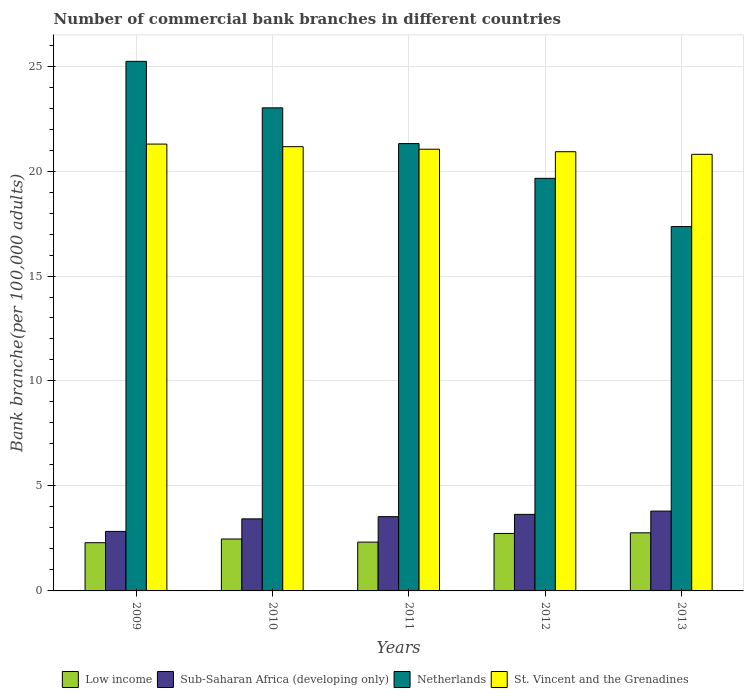Are the number of bars per tick equal to the number of legend labels?
Make the answer very short. Yes. What is the number of commercial bank branches in St. Vincent and the Grenadines in 2012?
Keep it short and to the point. 20.92. Across all years, what is the maximum number of commercial bank branches in St. Vincent and the Grenadines?
Keep it short and to the point. 21.28. Across all years, what is the minimum number of commercial bank branches in Netherlands?
Keep it short and to the point. 17.35. In which year was the number of commercial bank branches in St. Vincent and the Grenadines minimum?
Give a very brief answer. 2013. What is the total number of commercial bank branches in Low income in the graph?
Make the answer very short. 12.6. What is the difference between the number of commercial bank branches in Low income in 2011 and that in 2013?
Give a very brief answer. -0.44. What is the difference between the number of commercial bank branches in Sub-Saharan Africa (developing only) in 2010 and the number of commercial bank branches in Netherlands in 2012?
Your answer should be compact. -16.22. What is the average number of commercial bank branches in St. Vincent and the Grenadines per year?
Make the answer very short. 21.04. In the year 2013, what is the difference between the number of commercial bank branches in St. Vincent and the Grenadines and number of commercial bank branches in Low income?
Give a very brief answer. 18.03. What is the ratio of the number of commercial bank branches in St. Vincent and the Grenadines in 2009 to that in 2013?
Offer a terse response. 1.02. Is the difference between the number of commercial bank branches in St. Vincent and the Grenadines in 2009 and 2011 greater than the difference between the number of commercial bank branches in Low income in 2009 and 2011?
Offer a very short reply. Yes. What is the difference between the highest and the second highest number of commercial bank branches in Netherlands?
Make the answer very short. 2.21. What is the difference between the highest and the lowest number of commercial bank branches in Low income?
Offer a terse response. 0.47. In how many years, is the number of commercial bank branches in Sub-Saharan Africa (developing only) greater than the average number of commercial bank branches in Sub-Saharan Africa (developing only) taken over all years?
Your response must be concise. 3. What does the 2nd bar from the left in 2011 represents?
Make the answer very short. Sub-Saharan Africa (developing only). What does the 1st bar from the right in 2010 represents?
Give a very brief answer. St. Vincent and the Grenadines. Is it the case that in every year, the sum of the number of commercial bank branches in Netherlands and number of commercial bank branches in Sub-Saharan Africa (developing only) is greater than the number of commercial bank branches in Low income?
Ensure brevity in your answer.  Yes. What is the difference between two consecutive major ticks on the Y-axis?
Offer a terse response. 5. Are the values on the major ticks of Y-axis written in scientific E-notation?
Keep it short and to the point. No. How many legend labels are there?
Keep it short and to the point. 4. What is the title of the graph?
Provide a succinct answer. Number of commercial bank branches in different countries. What is the label or title of the Y-axis?
Provide a succinct answer. Bank branche(per 100,0 adults). What is the Bank branche(per 100,000 adults) in Low income in 2009?
Provide a succinct answer. 2.3. What is the Bank branche(per 100,000 adults) in Sub-Saharan Africa (developing only) in 2009?
Offer a very short reply. 2.83. What is the Bank branche(per 100,000 adults) in Netherlands in 2009?
Ensure brevity in your answer.  25.22. What is the Bank branche(per 100,000 adults) of St. Vincent and the Grenadines in 2009?
Your answer should be compact. 21.28. What is the Bank branche(per 100,000 adults) of Low income in 2010?
Ensure brevity in your answer.  2.47. What is the Bank branche(per 100,000 adults) of Sub-Saharan Africa (developing only) in 2010?
Offer a terse response. 3.43. What is the Bank branche(per 100,000 adults) in Netherlands in 2010?
Offer a terse response. 23.01. What is the Bank branche(per 100,000 adults) in St. Vincent and the Grenadines in 2010?
Ensure brevity in your answer.  21.16. What is the Bank branche(per 100,000 adults) of Low income in 2011?
Offer a terse response. 2.32. What is the Bank branche(per 100,000 adults) of Sub-Saharan Africa (developing only) in 2011?
Ensure brevity in your answer.  3.54. What is the Bank branche(per 100,000 adults) of Netherlands in 2011?
Your answer should be very brief. 21.31. What is the Bank branche(per 100,000 adults) of St. Vincent and the Grenadines in 2011?
Offer a terse response. 21.04. What is the Bank branche(per 100,000 adults) of Low income in 2012?
Give a very brief answer. 2.74. What is the Bank branche(per 100,000 adults) of Sub-Saharan Africa (developing only) in 2012?
Provide a short and direct response. 3.65. What is the Bank branche(per 100,000 adults) in Netherlands in 2012?
Make the answer very short. 19.65. What is the Bank branche(per 100,000 adults) of St. Vincent and the Grenadines in 2012?
Keep it short and to the point. 20.92. What is the Bank branche(per 100,000 adults) in Low income in 2013?
Offer a very short reply. 2.77. What is the Bank branche(per 100,000 adults) of Sub-Saharan Africa (developing only) in 2013?
Provide a succinct answer. 3.8. What is the Bank branche(per 100,000 adults) of Netherlands in 2013?
Provide a short and direct response. 17.35. What is the Bank branche(per 100,000 adults) in St. Vincent and the Grenadines in 2013?
Make the answer very short. 20.8. Across all years, what is the maximum Bank branche(per 100,000 adults) of Low income?
Offer a terse response. 2.77. Across all years, what is the maximum Bank branche(per 100,000 adults) in Sub-Saharan Africa (developing only)?
Keep it short and to the point. 3.8. Across all years, what is the maximum Bank branche(per 100,000 adults) in Netherlands?
Make the answer very short. 25.22. Across all years, what is the maximum Bank branche(per 100,000 adults) of St. Vincent and the Grenadines?
Your answer should be compact. 21.28. Across all years, what is the minimum Bank branche(per 100,000 adults) of Low income?
Give a very brief answer. 2.3. Across all years, what is the minimum Bank branche(per 100,000 adults) in Sub-Saharan Africa (developing only)?
Your response must be concise. 2.83. Across all years, what is the minimum Bank branche(per 100,000 adults) of Netherlands?
Offer a terse response. 17.35. Across all years, what is the minimum Bank branche(per 100,000 adults) in St. Vincent and the Grenadines?
Provide a succinct answer. 20.8. What is the total Bank branche(per 100,000 adults) of Low income in the graph?
Offer a very short reply. 12.6. What is the total Bank branche(per 100,000 adults) in Sub-Saharan Africa (developing only) in the graph?
Your answer should be very brief. 17.25. What is the total Bank branche(per 100,000 adults) in Netherlands in the graph?
Offer a very short reply. 106.55. What is the total Bank branche(per 100,000 adults) of St. Vincent and the Grenadines in the graph?
Offer a terse response. 105.2. What is the difference between the Bank branche(per 100,000 adults) in Low income in 2009 and that in 2010?
Your answer should be very brief. -0.18. What is the difference between the Bank branche(per 100,000 adults) of Sub-Saharan Africa (developing only) in 2009 and that in 2010?
Provide a short and direct response. -0.6. What is the difference between the Bank branche(per 100,000 adults) of Netherlands in 2009 and that in 2010?
Your answer should be very brief. 2.21. What is the difference between the Bank branche(per 100,000 adults) in St. Vincent and the Grenadines in 2009 and that in 2010?
Provide a succinct answer. 0.12. What is the difference between the Bank branche(per 100,000 adults) of Low income in 2009 and that in 2011?
Offer a terse response. -0.03. What is the difference between the Bank branche(per 100,000 adults) in Sub-Saharan Africa (developing only) in 2009 and that in 2011?
Ensure brevity in your answer.  -0.7. What is the difference between the Bank branche(per 100,000 adults) in Netherlands in 2009 and that in 2011?
Give a very brief answer. 3.92. What is the difference between the Bank branche(per 100,000 adults) in St. Vincent and the Grenadines in 2009 and that in 2011?
Your response must be concise. 0.24. What is the difference between the Bank branche(per 100,000 adults) in Low income in 2009 and that in 2012?
Your answer should be compact. -0.44. What is the difference between the Bank branche(per 100,000 adults) in Sub-Saharan Africa (developing only) in 2009 and that in 2012?
Keep it short and to the point. -0.81. What is the difference between the Bank branche(per 100,000 adults) in Netherlands in 2009 and that in 2012?
Your response must be concise. 5.57. What is the difference between the Bank branche(per 100,000 adults) in St. Vincent and the Grenadines in 2009 and that in 2012?
Ensure brevity in your answer.  0.36. What is the difference between the Bank branche(per 100,000 adults) in Low income in 2009 and that in 2013?
Your response must be concise. -0.47. What is the difference between the Bank branche(per 100,000 adults) of Sub-Saharan Africa (developing only) in 2009 and that in 2013?
Provide a short and direct response. -0.97. What is the difference between the Bank branche(per 100,000 adults) in Netherlands in 2009 and that in 2013?
Your answer should be very brief. 7.87. What is the difference between the Bank branche(per 100,000 adults) in St. Vincent and the Grenadines in 2009 and that in 2013?
Ensure brevity in your answer.  0.49. What is the difference between the Bank branche(per 100,000 adults) of Low income in 2010 and that in 2011?
Offer a terse response. 0.15. What is the difference between the Bank branche(per 100,000 adults) in Sub-Saharan Africa (developing only) in 2010 and that in 2011?
Your answer should be compact. -0.11. What is the difference between the Bank branche(per 100,000 adults) in Netherlands in 2010 and that in 2011?
Your answer should be compact. 1.7. What is the difference between the Bank branche(per 100,000 adults) in St. Vincent and the Grenadines in 2010 and that in 2011?
Your response must be concise. 0.12. What is the difference between the Bank branche(per 100,000 adults) in Low income in 2010 and that in 2012?
Provide a short and direct response. -0.26. What is the difference between the Bank branche(per 100,000 adults) of Sub-Saharan Africa (developing only) in 2010 and that in 2012?
Your response must be concise. -0.21. What is the difference between the Bank branche(per 100,000 adults) in Netherlands in 2010 and that in 2012?
Give a very brief answer. 3.36. What is the difference between the Bank branche(per 100,000 adults) in St. Vincent and the Grenadines in 2010 and that in 2012?
Make the answer very short. 0.24. What is the difference between the Bank branche(per 100,000 adults) in Low income in 2010 and that in 2013?
Provide a short and direct response. -0.3. What is the difference between the Bank branche(per 100,000 adults) in Sub-Saharan Africa (developing only) in 2010 and that in 2013?
Offer a very short reply. -0.37. What is the difference between the Bank branche(per 100,000 adults) of Netherlands in 2010 and that in 2013?
Offer a very short reply. 5.66. What is the difference between the Bank branche(per 100,000 adults) of St. Vincent and the Grenadines in 2010 and that in 2013?
Provide a short and direct response. 0.36. What is the difference between the Bank branche(per 100,000 adults) of Low income in 2011 and that in 2012?
Your answer should be compact. -0.41. What is the difference between the Bank branche(per 100,000 adults) in Sub-Saharan Africa (developing only) in 2011 and that in 2012?
Keep it short and to the point. -0.11. What is the difference between the Bank branche(per 100,000 adults) of Netherlands in 2011 and that in 2012?
Keep it short and to the point. 1.66. What is the difference between the Bank branche(per 100,000 adults) of St. Vincent and the Grenadines in 2011 and that in 2012?
Give a very brief answer. 0.12. What is the difference between the Bank branche(per 100,000 adults) in Low income in 2011 and that in 2013?
Your answer should be compact. -0.44. What is the difference between the Bank branche(per 100,000 adults) of Sub-Saharan Africa (developing only) in 2011 and that in 2013?
Ensure brevity in your answer.  -0.26. What is the difference between the Bank branche(per 100,000 adults) of Netherlands in 2011 and that in 2013?
Keep it short and to the point. 3.95. What is the difference between the Bank branche(per 100,000 adults) of St. Vincent and the Grenadines in 2011 and that in 2013?
Your answer should be very brief. 0.24. What is the difference between the Bank branche(per 100,000 adults) in Low income in 2012 and that in 2013?
Provide a succinct answer. -0.03. What is the difference between the Bank branche(per 100,000 adults) in Sub-Saharan Africa (developing only) in 2012 and that in 2013?
Keep it short and to the point. -0.16. What is the difference between the Bank branche(per 100,000 adults) of Netherlands in 2012 and that in 2013?
Provide a succinct answer. 2.3. What is the difference between the Bank branche(per 100,000 adults) in St. Vincent and the Grenadines in 2012 and that in 2013?
Offer a terse response. 0.12. What is the difference between the Bank branche(per 100,000 adults) of Low income in 2009 and the Bank branche(per 100,000 adults) of Sub-Saharan Africa (developing only) in 2010?
Your answer should be compact. -1.14. What is the difference between the Bank branche(per 100,000 adults) of Low income in 2009 and the Bank branche(per 100,000 adults) of Netherlands in 2010?
Keep it short and to the point. -20.71. What is the difference between the Bank branche(per 100,000 adults) of Low income in 2009 and the Bank branche(per 100,000 adults) of St. Vincent and the Grenadines in 2010?
Provide a succinct answer. -18.86. What is the difference between the Bank branche(per 100,000 adults) of Sub-Saharan Africa (developing only) in 2009 and the Bank branche(per 100,000 adults) of Netherlands in 2010?
Keep it short and to the point. -20.18. What is the difference between the Bank branche(per 100,000 adults) of Sub-Saharan Africa (developing only) in 2009 and the Bank branche(per 100,000 adults) of St. Vincent and the Grenadines in 2010?
Your response must be concise. -18.33. What is the difference between the Bank branche(per 100,000 adults) of Netherlands in 2009 and the Bank branche(per 100,000 adults) of St. Vincent and the Grenadines in 2010?
Your response must be concise. 4.06. What is the difference between the Bank branche(per 100,000 adults) in Low income in 2009 and the Bank branche(per 100,000 adults) in Sub-Saharan Africa (developing only) in 2011?
Your answer should be very brief. -1.24. What is the difference between the Bank branche(per 100,000 adults) in Low income in 2009 and the Bank branche(per 100,000 adults) in Netherlands in 2011?
Ensure brevity in your answer.  -19.01. What is the difference between the Bank branche(per 100,000 adults) in Low income in 2009 and the Bank branche(per 100,000 adults) in St. Vincent and the Grenadines in 2011?
Offer a very short reply. -18.74. What is the difference between the Bank branche(per 100,000 adults) of Sub-Saharan Africa (developing only) in 2009 and the Bank branche(per 100,000 adults) of Netherlands in 2011?
Keep it short and to the point. -18.47. What is the difference between the Bank branche(per 100,000 adults) of Sub-Saharan Africa (developing only) in 2009 and the Bank branche(per 100,000 adults) of St. Vincent and the Grenadines in 2011?
Keep it short and to the point. -18.2. What is the difference between the Bank branche(per 100,000 adults) of Netherlands in 2009 and the Bank branche(per 100,000 adults) of St. Vincent and the Grenadines in 2011?
Offer a terse response. 4.19. What is the difference between the Bank branche(per 100,000 adults) in Low income in 2009 and the Bank branche(per 100,000 adults) in Sub-Saharan Africa (developing only) in 2012?
Offer a terse response. -1.35. What is the difference between the Bank branche(per 100,000 adults) in Low income in 2009 and the Bank branche(per 100,000 adults) in Netherlands in 2012?
Your response must be concise. -17.35. What is the difference between the Bank branche(per 100,000 adults) of Low income in 2009 and the Bank branche(per 100,000 adults) of St. Vincent and the Grenadines in 2012?
Your answer should be compact. -18.62. What is the difference between the Bank branche(per 100,000 adults) in Sub-Saharan Africa (developing only) in 2009 and the Bank branche(per 100,000 adults) in Netherlands in 2012?
Offer a very short reply. -16.82. What is the difference between the Bank branche(per 100,000 adults) of Sub-Saharan Africa (developing only) in 2009 and the Bank branche(per 100,000 adults) of St. Vincent and the Grenadines in 2012?
Your answer should be very brief. -18.09. What is the difference between the Bank branche(per 100,000 adults) of Netherlands in 2009 and the Bank branche(per 100,000 adults) of St. Vincent and the Grenadines in 2012?
Provide a succinct answer. 4.3. What is the difference between the Bank branche(per 100,000 adults) of Low income in 2009 and the Bank branche(per 100,000 adults) of Sub-Saharan Africa (developing only) in 2013?
Provide a short and direct response. -1.51. What is the difference between the Bank branche(per 100,000 adults) of Low income in 2009 and the Bank branche(per 100,000 adults) of Netherlands in 2013?
Keep it short and to the point. -15.06. What is the difference between the Bank branche(per 100,000 adults) in Low income in 2009 and the Bank branche(per 100,000 adults) in St. Vincent and the Grenadines in 2013?
Provide a short and direct response. -18.5. What is the difference between the Bank branche(per 100,000 adults) in Sub-Saharan Africa (developing only) in 2009 and the Bank branche(per 100,000 adults) in Netherlands in 2013?
Keep it short and to the point. -14.52. What is the difference between the Bank branche(per 100,000 adults) in Sub-Saharan Africa (developing only) in 2009 and the Bank branche(per 100,000 adults) in St. Vincent and the Grenadines in 2013?
Provide a short and direct response. -17.96. What is the difference between the Bank branche(per 100,000 adults) in Netherlands in 2009 and the Bank branche(per 100,000 adults) in St. Vincent and the Grenadines in 2013?
Offer a terse response. 4.43. What is the difference between the Bank branche(per 100,000 adults) in Low income in 2010 and the Bank branche(per 100,000 adults) in Sub-Saharan Africa (developing only) in 2011?
Keep it short and to the point. -1.06. What is the difference between the Bank branche(per 100,000 adults) of Low income in 2010 and the Bank branche(per 100,000 adults) of Netherlands in 2011?
Offer a very short reply. -18.83. What is the difference between the Bank branche(per 100,000 adults) in Low income in 2010 and the Bank branche(per 100,000 adults) in St. Vincent and the Grenadines in 2011?
Provide a succinct answer. -18.57. What is the difference between the Bank branche(per 100,000 adults) of Sub-Saharan Africa (developing only) in 2010 and the Bank branche(per 100,000 adults) of Netherlands in 2011?
Your response must be concise. -17.88. What is the difference between the Bank branche(per 100,000 adults) in Sub-Saharan Africa (developing only) in 2010 and the Bank branche(per 100,000 adults) in St. Vincent and the Grenadines in 2011?
Your response must be concise. -17.61. What is the difference between the Bank branche(per 100,000 adults) in Netherlands in 2010 and the Bank branche(per 100,000 adults) in St. Vincent and the Grenadines in 2011?
Your answer should be compact. 1.97. What is the difference between the Bank branche(per 100,000 adults) of Low income in 2010 and the Bank branche(per 100,000 adults) of Sub-Saharan Africa (developing only) in 2012?
Keep it short and to the point. -1.17. What is the difference between the Bank branche(per 100,000 adults) of Low income in 2010 and the Bank branche(per 100,000 adults) of Netherlands in 2012?
Offer a very short reply. -17.18. What is the difference between the Bank branche(per 100,000 adults) of Low income in 2010 and the Bank branche(per 100,000 adults) of St. Vincent and the Grenadines in 2012?
Your answer should be compact. -18.45. What is the difference between the Bank branche(per 100,000 adults) of Sub-Saharan Africa (developing only) in 2010 and the Bank branche(per 100,000 adults) of Netherlands in 2012?
Provide a succinct answer. -16.22. What is the difference between the Bank branche(per 100,000 adults) in Sub-Saharan Africa (developing only) in 2010 and the Bank branche(per 100,000 adults) in St. Vincent and the Grenadines in 2012?
Your response must be concise. -17.49. What is the difference between the Bank branche(per 100,000 adults) of Netherlands in 2010 and the Bank branche(per 100,000 adults) of St. Vincent and the Grenadines in 2012?
Keep it short and to the point. 2.09. What is the difference between the Bank branche(per 100,000 adults) in Low income in 2010 and the Bank branche(per 100,000 adults) in Sub-Saharan Africa (developing only) in 2013?
Offer a terse response. -1.33. What is the difference between the Bank branche(per 100,000 adults) of Low income in 2010 and the Bank branche(per 100,000 adults) of Netherlands in 2013?
Ensure brevity in your answer.  -14.88. What is the difference between the Bank branche(per 100,000 adults) in Low income in 2010 and the Bank branche(per 100,000 adults) in St. Vincent and the Grenadines in 2013?
Provide a short and direct response. -18.32. What is the difference between the Bank branche(per 100,000 adults) in Sub-Saharan Africa (developing only) in 2010 and the Bank branche(per 100,000 adults) in Netherlands in 2013?
Your response must be concise. -13.92. What is the difference between the Bank branche(per 100,000 adults) in Sub-Saharan Africa (developing only) in 2010 and the Bank branche(per 100,000 adults) in St. Vincent and the Grenadines in 2013?
Give a very brief answer. -17.36. What is the difference between the Bank branche(per 100,000 adults) of Netherlands in 2010 and the Bank branche(per 100,000 adults) of St. Vincent and the Grenadines in 2013?
Make the answer very short. 2.21. What is the difference between the Bank branche(per 100,000 adults) of Low income in 2011 and the Bank branche(per 100,000 adults) of Sub-Saharan Africa (developing only) in 2012?
Offer a very short reply. -1.32. What is the difference between the Bank branche(per 100,000 adults) in Low income in 2011 and the Bank branche(per 100,000 adults) in Netherlands in 2012?
Keep it short and to the point. -17.33. What is the difference between the Bank branche(per 100,000 adults) of Low income in 2011 and the Bank branche(per 100,000 adults) of St. Vincent and the Grenadines in 2012?
Your answer should be very brief. -18.6. What is the difference between the Bank branche(per 100,000 adults) of Sub-Saharan Africa (developing only) in 2011 and the Bank branche(per 100,000 adults) of Netherlands in 2012?
Ensure brevity in your answer.  -16.11. What is the difference between the Bank branche(per 100,000 adults) of Sub-Saharan Africa (developing only) in 2011 and the Bank branche(per 100,000 adults) of St. Vincent and the Grenadines in 2012?
Offer a terse response. -17.38. What is the difference between the Bank branche(per 100,000 adults) in Netherlands in 2011 and the Bank branche(per 100,000 adults) in St. Vincent and the Grenadines in 2012?
Provide a short and direct response. 0.39. What is the difference between the Bank branche(per 100,000 adults) in Low income in 2011 and the Bank branche(per 100,000 adults) in Sub-Saharan Africa (developing only) in 2013?
Your answer should be compact. -1.48. What is the difference between the Bank branche(per 100,000 adults) of Low income in 2011 and the Bank branche(per 100,000 adults) of Netherlands in 2013?
Offer a terse response. -15.03. What is the difference between the Bank branche(per 100,000 adults) of Low income in 2011 and the Bank branche(per 100,000 adults) of St. Vincent and the Grenadines in 2013?
Make the answer very short. -18.47. What is the difference between the Bank branche(per 100,000 adults) in Sub-Saharan Africa (developing only) in 2011 and the Bank branche(per 100,000 adults) in Netherlands in 2013?
Your answer should be compact. -13.82. What is the difference between the Bank branche(per 100,000 adults) of Sub-Saharan Africa (developing only) in 2011 and the Bank branche(per 100,000 adults) of St. Vincent and the Grenadines in 2013?
Your answer should be compact. -17.26. What is the difference between the Bank branche(per 100,000 adults) of Netherlands in 2011 and the Bank branche(per 100,000 adults) of St. Vincent and the Grenadines in 2013?
Offer a very short reply. 0.51. What is the difference between the Bank branche(per 100,000 adults) of Low income in 2012 and the Bank branche(per 100,000 adults) of Sub-Saharan Africa (developing only) in 2013?
Provide a succinct answer. -1.07. What is the difference between the Bank branche(per 100,000 adults) of Low income in 2012 and the Bank branche(per 100,000 adults) of Netherlands in 2013?
Offer a very short reply. -14.62. What is the difference between the Bank branche(per 100,000 adults) in Low income in 2012 and the Bank branche(per 100,000 adults) in St. Vincent and the Grenadines in 2013?
Ensure brevity in your answer.  -18.06. What is the difference between the Bank branche(per 100,000 adults) in Sub-Saharan Africa (developing only) in 2012 and the Bank branche(per 100,000 adults) in Netherlands in 2013?
Keep it short and to the point. -13.71. What is the difference between the Bank branche(per 100,000 adults) of Sub-Saharan Africa (developing only) in 2012 and the Bank branche(per 100,000 adults) of St. Vincent and the Grenadines in 2013?
Provide a succinct answer. -17.15. What is the difference between the Bank branche(per 100,000 adults) in Netherlands in 2012 and the Bank branche(per 100,000 adults) in St. Vincent and the Grenadines in 2013?
Offer a terse response. -1.14. What is the average Bank branche(per 100,000 adults) in Low income per year?
Provide a succinct answer. 2.52. What is the average Bank branche(per 100,000 adults) of Sub-Saharan Africa (developing only) per year?
Ensure brevity in your answer.  3.45. What is the average Bank branche(per 100,000 adults) in Netherlands per year?
Your answer should be compact. 21.31. What is the average Bank branche(per 100,000 adults) in St. Vincent and the Grenadines per year?
Give a very brief answer. 21.04. In the year 2009, what is the difference between the Bank branche(per 100,000 adults) in Low income and Bank branche(per 100,000 adults) in Sub-Saharan Africa (developing only)?
Your answer should be compact. -0.54. In the year 2009, what is the difference between the Bank branche(per 100,000 adults) in Low income and Bank branche(per 100,000 adults) in Netherlands?
Provide a succinct answer. -22.93. In the year 2009, what is the difference between the Bank branche(per 100,000 adults) in Low income and Bank branche(per 100,000 adults) in St. Vincent and the Grenadines?
Offer a terse response. -18.99. In the year 2009, what is the difference between the Bank branche(per 100,000 adults) in Sub-Saharan Africa (developing only) and Bank branche(per 100,000 adults) in Netherlands?
Your answer should be very brief. -22.39. In the year 2009, what is the difference between the Bank branche(per 100,000 adults) of Sub-Saharan Africa (developing only) and Bank branche(per 100,000 adults) of St. Vincent and the Grenadines?
Provide a short and direct response. -18.45. In the year 2009, what is the difference between the Bank branche(per 100,000 adults) in Netherlands and Bank branche(per 100,000 adults) in St. Vincent and the Grenadines?
Provide a succinct answer. 3.94. In the year 2010, what is the difference between the Bank branche(per 100,000 adults) in Low income and Bank branche(per 100,000 adults) in Sub-Saharan Africa (developing only)?
Offer a very short reply. -0.96. In the year 2010, what is the difference between the Bank branche(per 100,000 adults) of Low income and Bank branche(per 100,000 adults) of Netherlands?
Keep it short and to the point. -20.54. In the year 2010, what is the difference between the Bank branche(per 100,000 adults) of Low income and Bank branche(per 100,000 adults) of St. Vincent and the Grenadines?
Your answer should be compact. -18.69. In the year 2010, what is the difference between the Bank branche(per 100,000 adults) of Sub-Saharan Africa (developing only) and Bank branche(per 100,000 adults) of Netherlands?
Keep it short and to the point. -19.58. In the year 2010, what is the difference between the Bank branche(per 100,000 adults) in Sub-Saharan Africa (developing only) and Bank branche(per 100,000 adults) in St. Vincent and the Grenadines?
Provide a short and direct response. -17.73. In the year 2010, what is the difference between the Bank branche(per 100,000 adults) in Netherlands and Bank branche(per 100,000 adults) in St. Vincent and the Grenadines?
Keep it short and to the point. 1.85. In the year 2011, what is the difference between the Bank branche(per 100,000 adults) in Low income and Bank branche(per 100,000 adults) in Sub-Saharan Africa (developing only)?
Keep it short and to the point. -1.21. In the year 2011, what is the difference between the Bank branche(per 100,000 adults) of Low income and Bank branche(per 100,000 adults) of Netherlands?
Make the answer very short. -18.98. In the year 2011, what is the difference between the Bank branche(per 100,000 adults) of Low income and Bank branche(per 100,000 adults) of St. Vincent and the Grenadines?
Provide a succinct answer. -18.71. In the year 2011, what is the difference between the Bank branche(per 100,000 adults) in Sub-Saharan Africa (developing only) and Bank branche(per 100,000 adults) in Netherlands?
Provide a short and direct response. -17.77. In the year 2011, what is the difference between the Bank branche(per 100,000 adults) in Sub-Saharan Africa (developing only) and Bank branche(per 100,000 adults) in St. Vincent and the Grenadines?
Your answer should be compact. -17.5. In the year 2011, what is the difference between the Bank branche(per 100,000 adults) of Netherlands and Bank branche(per 100,000 adults) of St. Vincent and the Grenadines?
Your response must be concise. 0.27. In the year 2012, what is the difference between the Bank branche(per 100,000 adults) in Low income and Bank branche(per 100,000 adults) in Sub-Saharan Africa (developing only)?
Keep it short and to the point. -0.91. In the year 2012, what is the difference between the Bank branche(per 100,000 adults) of Low income and Bank branche(per 100,000 adults) of Netherlands?
Make the answer very short. -16.91. In the year 2012, what is the difference between the Bank branche(per 100,000 adults) of Low income and Bank branche(per 100,000 adults) of St. Vincent and the Grenadines?
Provide a short and direct response. -18.18. In the year 2012, what is the difference between the Bank branche(per 100,000 adults) of Sub-Saharan Africa (developing only) and Bank branche(per 100,000 adults) of Netherlands?
Your answer should be very brief. -16.01. In the year 2012, what is the difference between the Bank branche(per 100,000 adults) of Sub-Saharan Africa (developing only) and Bank branche(per 100,000 adults) of St. Vincent and the Grenadines?
Keep it short and to the point. -17.27. In the year 2012, what is the difference between the Bank branche(per 100,000 adults) in Netherlands and Bank branche(per 100,000 adults) in St. Vincent and the Grenadines?
Keep it short and to the point. -1.27. In the year 2013, what is the difference between the Bank branche(per 100,000 adults) of Low income and Bank branche(per 100,000 adults) of Sub-Saharan Africa (developing only)?
Provide a short and direct response. -1.03. In the year 2013, what is the difference between the Bank branche(per 100,000 adults) of Low income and Bank branche(per 100,000 adults) of Netherlands?
Ensure brevity in your answer.  -14.59. In the year 2013, what is the difference between the Bank branche(per 100,000 adults) of Low income and Bank branche(per 100,000 adults) of St. Vincent and the Grenadines?
Your response must be concise. -18.03. In the year 2013, what is the difference between the Bank branche(per 100,000 adults) in Sub-Saharan Africa (developing only) and Bank branche(per 100,000 adults) in Netherlands?
Your answer should be very brief. -13.55. In the year 2013, what is the difference between the Bank branche(per 100,000 adults) of Sub-Saharan Africa (developing only) and Bank branche(per 100,000 adults) of St. Vincent and the Grenadines?
Make the answer very short. -16.99. In the year 2013, what is the difference between the Bank branche(per 100,000 adults) of Netherlands and Bank branche(per 100,000 adults) of St. Vincent and the Grenadines?
Offer a terse response. -3.44. What is the ratio of the Bank branche(per 100,000 adults) in Sub-Saharan Africa (developing only) in 2009 to that in 2010?
Give a very brief answer. 0.83. What is the ratio of the Bank branche(per 100,000 adults) in Netherlands in 2009 to that in 2010?
Provide a succinct answer. 1.1. What is the ratio of the Bank branche(per 100,000 adults) in Sub-Saharan Africa (developing only) in 2009 to that in 2011?
Your answer should be compact. 0.8. What is the ratio of the Bank branche(per 100,000 adults) of Netherlands in 2009 to that in 2011?
Keep it short and to the point. 1.18. What is the ratio of the Bank branche(per 100,000 adults) of St. Vincent and the Grenadines in 2009 to that in 2011?
Ensure brevity in your answer.  1.01. What is the ratio of the Bank branche(per 100,000 adults) in Low income in 2009 to that in 2012?
Ensure brevity in your answer.  0.84. What is the ratio of the Bank branche(per 100,000 adults) of Sub-Saharan Africa (developing only) in 2009 to that in 2012?
Your answer should be very brief. 0.78. What is the ratio of the Bank branche(per 100,000 adults) of Netherlands in 2009 to that in 2012?
Your answer should be compact. 1.28. What is the ratio of the Bank branche(per 100,000 adults) in St. Vincent and the Grenadines in 2009 to that in 2012?
Offer a terse response. 1.02. What is the ratio of the Bank branche(per 100,000 adults) of Low income in 2009 to that in 2013?
Provide a short and direct response. 0.83. What is the ratio of the Bank branche(per 100,000 adults) of Sub-Saharan Africa (developing only) in 2009 to that in 2013?
Keep it short and to the point. 0.75. What is the ratio of the Bank branche(per 100,000 adults) of Netherlands in 2009 to that in 2013?
Ensure brevity in your answer.  1.45. What is the ratio of the Bank branche(per 100,000 adults) in St. Vincent and the Grenadines in 2009 to that in 2013?
Your answer should be very brief. 1.02. What is the ratio of the Bank branche(per 100,000 adults) of Low income in 2010 to that in 2011?
Offer a terse response. 1.06. What is the ratio of the Bank branche(per 100,000 adults) of Sub-Saharan Africa (developing only) in 2010 to that in 2011?
Provide a succinct answer. 0.97. What is the ratio of the Bank branche(per 100,000 adults) of Netherlands in 2010 to that in 2011?
Your response must be concise. 1.08. What is the ratio of the Bank branche(per 100,000 adults) of Low income in 2010 to that in 2012?
Offer a very short reply. 0.9. What is the ratio of the Bank branche(per 100,000 adults) in Sub-Saharan Africa (developing only) in 2010 to that in 2012?
Offer a very short reply. 0.94. What is the ratio of the Bank branche(per 100,000 adults) in Netherlands in 2010 to that in 2012?
Give a very brief answer. 1.17. What is the ratio of the Bank branche(per 100,000 adults) in St. Vincent and the Grenadines in 2010 to that in 2012?
Provide a short and direct response. 1.01. What is the ratio of the Bank branche(per 100,000 adults) in Low income in 2010 to that in 2013?
Provide a succinct answer. 0.89. What is the ratio of the Bank branche(per 100,000 adults) of Sub-Saharan Africa (developing only) in 2010 to that in 2013?
Your answer should be compact. 0.9. What is the ratio of the Bank branche(per 100,000 adults) of Netherlands in 2010 to that in 2013?
Keep it short and to the point. 1.33. What is the ratio of the Bank branche(per 100,000 adults) in St. Vincent and the Grenadines in 2010 to that in 2013?
Give a very brief answer. 1.02. What is the ratio of the Bank branche(per 100,000 adults) of Low income in 2011 to that in 2012?
Offer a very short reply. 0.85. What is the ratio of the Bank branche(per 100,000 adults) of Sub-Saharan Africa (developing only) in 2011 to that in 2012?
Make the answer very short. 0.97. What is the ratio of the Bank branche(per 100,000 adults) in Netherlands in 2011 to that in 2012?
Offer a very short reply. 1.08. What is the ratio of the Bank branche(per 100,000 adults) of St. Vincent and the Grenadines in 2011 to that in 2012?
Provide a succinct answer. 1.01. What is the ratio of the Bank branche(per 100,000 adults) of Low income in 2011 to that in 2013?
Make the answer very short. 0.84. What is the ratio of the Bank branche(per 100,000 adults) of Sub-Saharan Africa (developing only) in 2011 to that in 2013?
Offer a very short reply. 0.93. What is the ratio of the Bank branche(per 100,000 adults) in Netherlands in 2011 to that in 2013?
Offer a very short reply. 1.23. What is the ratio of the Bank branche(per 100,000 adults) in St. Vincent and the Grenadines in 2011 to that in 2013?
Your answer should be compact. 1.01. What is the ratio of the Bank branche(per 100,000 adults) of Sub-Saharan Africa (developing only) in 2012 to that in 2013?
Make the answer very short. 0.96. What is the ratio of the Bank branche(per 100,000 adults) in Netherlands in 2012 to that in 2013?
Offer a very short reply. 1.13. What is the difference between the highest and the second highest Bank branche(per 100,000 adults) of Low income?
Offer a terse response. 0.03. What is the difference between the highest and the second highest Bank branche(per 100,000 adults) in Sub-Saharan Africa (developing only)?
Your response must be concise. 0.16. What is the difference between the highest and the second highest Bank branche(per 100,000 adults) of Netherlands?
Give a very brief answer. 2.21. What is the difference between the highest and the second highest Bank branche(per 100,000 adults) of St. Vincent and the Grenadines?
Make the answer very short. 0.12. What is the difference between the highest and the lowest Bank branche(per 100,000 adults) of Low income?
Make the answer very short. 0.47. What is the difference between the highest and the lowest Bank branche(per 100,000 adults) of Sub-Saharan Africa (developing only)?
Your response must be concise. 0.97. What is the difference between the highest and the lowest Bank branche(per 100,000 adults) in Netherlands?
Provide a short and direct response. 7.87. What is the difference between the highest and the lowest Bank branche(per 100,000 adults) of St. Vincent and the Grenadines?
Your response must be concise. 0.49. 